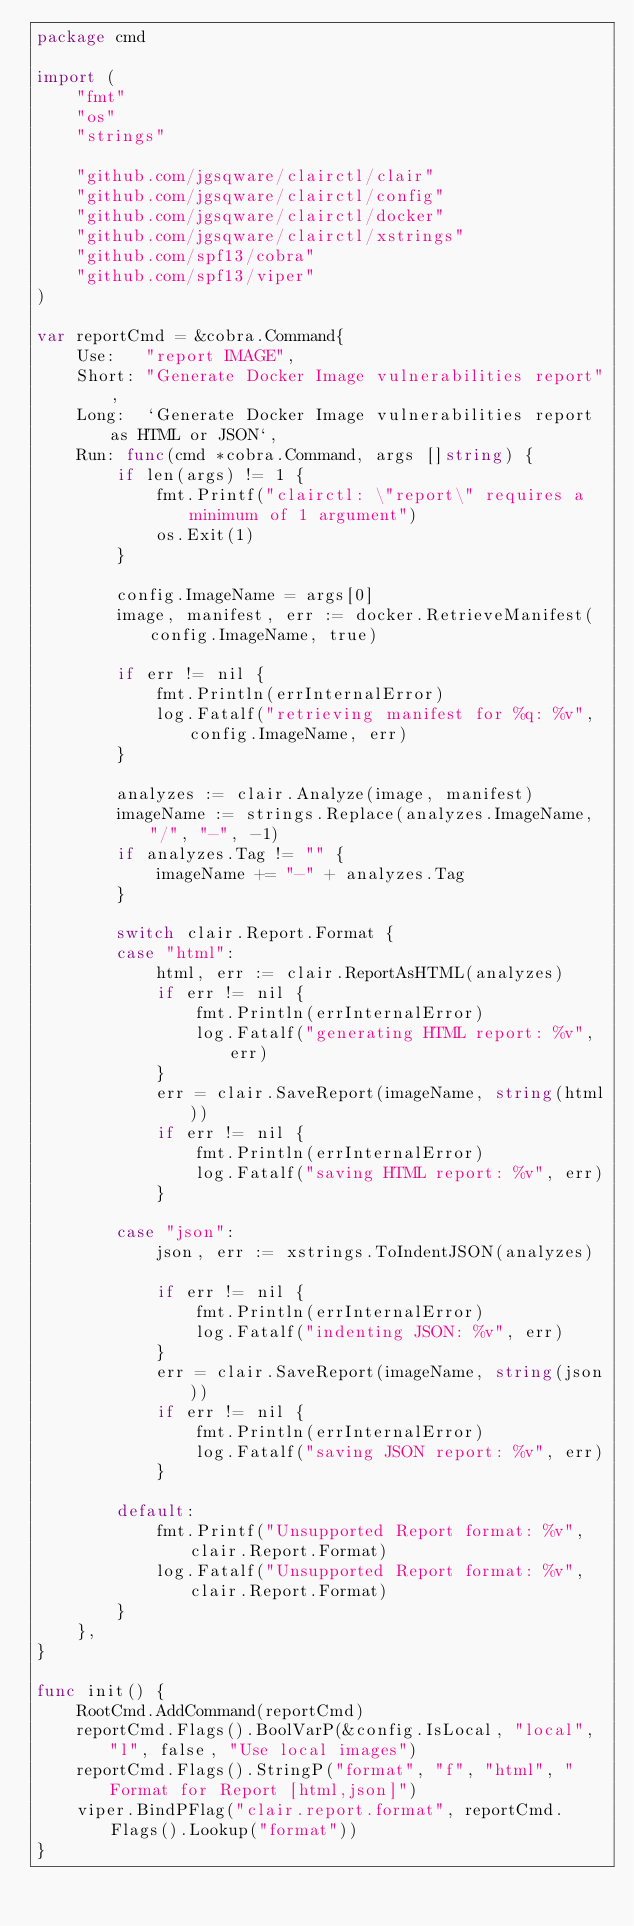Convert code to text. <code><loc_0><loc_0><loc_500><loc_500><_Go_>package cmd

import (
	"fmt"
	"os"
	"strings"

	"github.com/jgsqware/clairctl/clair"
	"github.com/jgsqware/clairctl/config"
	"github.com/jgsqware/clairctl/docker"
	"github.com/jgsqware/clairctl/xstrings"
	"github.com/spf13/cobra"
	"github.com/spf13/viper"
)

var reportCmd = &cobra.Command{
	Use:   "report IMAGE",
	Short: "Generate Docker Image vulnerabilities report",
	Long:  `Generate Docker Image vulnerabilities report as HTML or JSON`,
	Run: func(cmd *cobra.Command, args []string) {
		if len(args) != 1 {
			fmt.Printf("clairctl: \"report\" requires a minimum of 1 argument")
			os.Exit(1)
		}

		config.ImageName = args[0]
		image, manifest, err := docker.RetrieveManifest(config.ImageName, true)

		if err != nil {
			fmt.Println(errInternalError)
			log.Fatalf("retrieving manifest for %q: %v", config.ImageName, err)
		}

		analyzes := clair.Analyze(image, manifest)
		imageName := strings.Replace(analyzes.ImageName, "/", "-", -1)
		if analyzes.Tag != "" {
			imageName += "-" + analyzes.Tag
		}

		switch clair.Report.Format {
		case "html":
			html, err := clair.ReportAsHTML(analyzes)
			if err != nil {
				fmt.Println(errInternalError)
				log.Fatalf("generating HTML report: %v", err)
			}
			err = clair.SaveReport(imageName, string(html))
			if err != nil {
				fmt.Println(errInternalError)
				log.Fatalf("saving HTML report: %v", err)
			}

		case "json":
			json, err := xstrings.ToIndentJSON(analyzes)

			if err != nil {
				fmt.Println(errInternalError)
				log.Fatalf("indenting JSON: %v", err)
			}
			err = clair.SaveReport(imageName, string(json))
			if err != nil {
				fmt.Println(errInternalError)
				log.Fatalf("saving JSON report: %v", err)
			}

		default:
			fmt.Printf("Unsupported Report format: %v", clair.Report.Format)
			log.Fatalf("Unsupported Report format: %v", clair.Report.Format)
		}
	},
}

func init() {
	RootCmd.AddCommand(reportCmd)
	reportCmd.Flags().BoolVarP(&config.IsLocal, "local", "l", false, "Use local images")
	reportCmd.Flags().StringP("format", "f", "html", "Format for Report [html,json]")
	viper.BindPFlag("clair.report.format", reportCmd.Flags().Lookup("format"))
}
</code> 